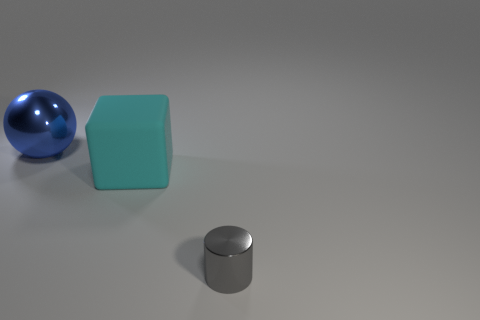Is there another large cyan object that has the same material as the big cyan object?
Provide a short and direct response. No. What is the material of the large object that is on the right side of the metallic thing behind the small metallic cylinder?
Your answer should be compact. Rubber. There is a shiny object behind the tiny gray metal thing; what is its size?
Offer a very short reply. Large. Do the cylinder and the metal object that is to the left of the small cylinder have the same color?
Give a very brief answer. No. Are there any big objects of the same color as the matte block?
Your answer should be compact. No. Does the cylinder have the same material as the large thing that is on the right side of the big blue object?
Provide a succinct answer. No. How many small objects are cyan matte things or yellow metallic spheres?
Ensure brevity in your answer.  0. Is the number of large cyan matte objects less than the number of small yellow things?
Offer a very short reply. No. Do the metallic object in front of the cyan matte thing and the shiny object left of the gray metallic cylinder have the same size?
Give a very brief answer. No. How many gray things are either big blocks or tiny metal things?
Provide a succinct answer. 1. 